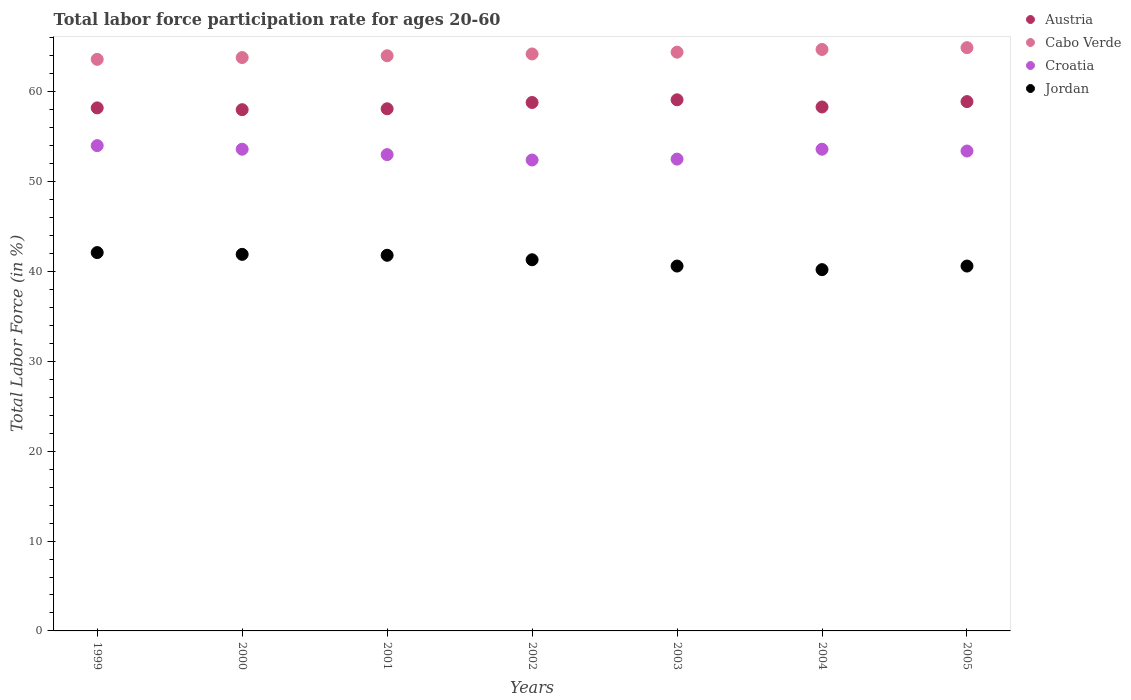How many different coloured dotlines are there?
Give a very brief answer. 4. Is the number of dotlines equal to the number of legend labels?
Your answer should be compact. Yes. What is the labor force participation rate in Austria in 2001?
Your response must be concise. 58.1. Across all years, what is the maximum labor force participation rate in Austria?
Your answer should be very brief. 59.1. Across all years, what is the minimum labor force participation rate in Croatia?
Your answer should be compact. 52.4. In which year was the labor force participation rate in Cabo Verde maximum?
Give a very brief answer. 2005. What is the total labor force participation rate in Cabo Verde in the graph?
Offer a terse response. 449.6. What is the difference between the labor force participation rate in Jordan in 1999 and that in 2004?
Your answer should be compact. 1.9. What is the difference between the labor force participation rate in Croatia in 1999 and the labor force participation rate in Cabo Verde in 2001?
Your response must be concise. -10. What is the average labor force participation rate in Austria per year?
Your answer should be compact. 58.49. In the year 1999, what is the difference between the labor force participation rate in Austria and labor force participation rate in Croatia?
Ensure brevity in your answer.  4.2. In how many years, is the labor force participation rate in Cabo Verde greater than 56 %?
Ensure brevity in your answer.  7. What is the ratio of the labor force participation rate in Cabo Verde in 2002 to that in 2004?
Provide a short and direct response. 0.99. Is the labor force participation rate in Croatia in 2001 less than that in 2003?
Your answer should be very brief. No. Is the difference between the labor force participation rate in Austria in 1999 and 2005 greater than the difference between the labor force participation rate in Croatia in 1999 and 2005?
Offer a terse response. No. What is the difference between the highest and the second highest labor force participation rate in Cabo Verde?
Make the answer very short. 0.2. What is the difference between the highest and the lowest labor force participation rate in Austria?
Give a very brief answer. 1.1. Is the sum of the labor force participation rate in Cabo Verde in 1999 and 2001 greater than the maximum labor force participation rate in Austria across all years?
Ensure brevity in your answer.  Yes. Is it the case that in every year, the sum of the labor force participation rate in Croatia and labor force participation rate in Austria  is greater than the sum of labor force participation rate in Jordan and labor force participation rate in Cabo Verde?
Your answer should be very brief. Yes. Is it the case that in every year, the sum of the labor force participation rate in Croatia and labor force participation rate in Jordan  is greater than the labor force participation rate in Austria?
Offer a very short reply. Yes. How many dotlines are there?
Give a very brief answer. 4. Does the graph contain any zero values?
Keep it short and to the point. No. Where does the legend appear in the graph?
Your answer should be compact. Top right. What is the title of the graph?
Keep it short and to the point. Total labor force participation rate for ages 20-60. Does "Least developed countries" appear as one of the legend labels in the graph?
Provide a succinct answer. No. What is the Total Labor Force (in %) of Austria in 1999?
Your response must be concise. 58.2. What is the Total Labor Force (in %) in Cabo Verde in 1999?
Keep it short and to the point. 63.6. What is the Total Labor Force (in %) in Croatia in 1999?
Your answer should be very brief. 54. What is the Total Labor Force (in %) of Jordan in 1999?
Offer a very short reply. 42.1. What is the Total Labor Force (in %) of Austria in 2000?
Make the answer very short. 58. What is the Total Labor Force (in %) in Cabo Verde in 2000?
Keep it short and to the point. 63.8. What is the Total Labor Force (in %) in Croatia in 2000?
Ensure brevity in your answer.  53.6. What is the Total Labor Force (in %) in Jordan in 2000?
Keep it short and to the point. 41.9. What is the Total Labor Force (in %) of Austria in 2001?
Provide a succinct answer. 58.1. What is the Total Labor Force (in %) of Cabo Verde in 2001?
Offer a terse response. 64. What is the Total Labor Force (in %) of Croatia in 2001?
Provide a short and direct response. 53. What is the Total Labor Force (in %) of Jordan in 2001?
Provide a short and direct response. 41.8. What is the Total Labor Force (in %) of Austria in 2002?
Your answer should be very brief. 58.8. What is the Total Labor Force (in %) of Cabo Verde in 2002?
Ensure brevity in your answer.  64.2. What is the Total Labor Force (in %) in Croatia in 2002?
Make the answer very short. 52.4. What is the Total Labor Force (in %) in Jordan in 2002?
Keep it short and to the point. 41.3. What is the Total Labor Force (in %) in Austria in 2003?
Provide a short and direct response. 59.1. What is the Total Labor Force (in %) of Cabo Verde in 2003?
Give a very brief answer. 64.4. What is the Total Labor Force (in %) in Croatia in 2003?
Your answer should be compact. 52.5. What is the Total Labor Force (in %) of Jordan in 2003?
Your answer should be compact. 40.6. What is the Total Labor Force (in %) of Austria in 2004?
Offer a terse response. 58.3. What is the Total Labor Force (in %) of Cabo Verde in 2004?
Offer a terse response. 64.7. What is the Total Labor Force (in %) of Croatia in 2004?
Your response must be concise. 53.6. What is the Total Labor Force (in %) of Jordan in 2004?
Offer a very short reply. 40.2. What is the Total Labor Force (in %) of Austria in 2005?
Your answer should be very brief. 58.9. What is the Total Labor Force (in %) in Cabo Verde in 2005?
Your answer should be compact. 64.9. What is the Total Labor Force (in %) in Croatia in 2005?
Ensure brevity in your answer.  53.4. What is the Total Labor Force (in %) in Jordan in 2005?
Your response must be concise. 40.6. Across all years, what is the maximum Total Labor Force (in %) in Austria?
Ensure brevity in your answer.  59.1. Across all years, what is the maximum Total Labor Force (in %) of Cabo Verde?
Offer a very short reply. 64.9. Across all years, what is the maximum Total Labor Force (in %) of Croatia?
Your answer should be very brief. 54. Across all years, what is the maximum Total Labor Force (in %) of Jordan?
Provide a short and direct response. 42.1. Across all years, what is the minimum Total Labor Force (in %) in Austria?
Your response must be concise. 58. Across all years, what is the minimum Total Labor Force (in %) of Cabo Verde?
Your response must be concise. 63.6. Across all years, what is the minimum Total Labor Force (in %) in Croatia?
Offer a terse response. 52.4. Across all years, what is the minimum Total Labor Force (in %) in Jordan?
Ensure brevity in your answer.  40.2. What is the total Total Labor Force (in %) of Austria in the graph?
Give a very brief answer. 409.4. What is the total Total Labor Force (in %) of Cabo Verde in the graph?
Provide a short and direct response. 449.6. What is the total Total Labor Force (in %) in Croatia in the graph?
Provide a short and direct response. 372.5. What is the total Total Labor Force (in %) of Jordan in the graph?
Provide a succinct answer. 288.5. What is the difference between the Total Labor Force (in %) of Austria in 1999 and that in 2000?
Keep it short and to the point. 0.2. What is the difference between the Total Labor Force (in %) in Croatia in 1999 and that in 2000?
Ensure brevity in your answer.  0.4. What is the difference between the Total Labor Force (in %) in Jordan in 1999 and that in 2000?
Give a very brief answer. 0.2. What is the difference between the Total Labor Force (in %) of Austria in 1999 and that in 2001?
Offer a very short reply. 0.1. What is the difference between the Total Labor Force (in %) in Cabo Verde in 1999 and that in 2001?
Your answer should be very brief. -0.4. What is the difference between the Total Labor Force (in %) of Croatia in 1999 and that in 2001?
Provide a short and direct response. 1. What is the difference between the Total Labor Force (in %) of Jordan in 1999 and that in 2001?
Give a very brief answer. 0.3. What is the difference between the Total Labor Force (in %) of Austria in 1999 and that in 2002?
Provide a short and direct response. -0.6. What is the difference between the Total Labor Force (in %) in Cabo Verde in 1999 and that in 2002?
Provide a short and direct response. -0.6. What is the difference between the Total Labor Force (in %) of Jordan in 1999 and that in 2002?
Offer a very short reply. 0.8. What is the difference between the Total Labor Force (in %) in Austria in 1999 and that in 2003?
Provide a succinct answer. -0.9. What is the difference between the Total Labor Force (in %) of Austria in 1999 and that in 2004?
Make the answer very short. -0.1. What is the difference between the Total Labor Force (in %) of Cabo Verde in 1999 and that in 2004?
Provide a succinct answer. -1.1. What is the difference between the Total Labor Force (in %) of Croatia in 1999 and that in 2004?
Make the answer very short. 0.4. What is the difference between the Total Labor Force (in %) in Jordan in 1999 and that in 2004?
Make the answer very short. 1.9. What is the difference between the Total Labor Force (in %) of Austria in 1999 and that in 2005?
Your answer should be very brief. -0.7. What is the difference between the Total Labor Force (in %) in Cabo Verde in 1999 and that in 2005?
Make the answer very short. -1.3. What is the difference between the Total Labor Force (in %) of Jordan in 1999 and that in 2005?
Make the answer very short. 1.5. What is the difference between the Total Labor Force (in %) in Croatia in 2000 and that in 2001?
Keep it short and to the point. 0.6. What is the difference between the Total Labor Force (in %) in Austria in 2000 and that in 2002?
Make the answer very short. -0.8. What is the difference between the Total Labor Force (in %) in Cabo Verde in 2000 and that in 2002?
Keep it short and to the point. -0.4. What is the difference between the Total Labor Force (in %) of Croatia in 2000 and that in 2002?
Provide a succinct answer. 1.2. What is the difference between the Total Labor Force (in %) in Austria in 2000 and that in 2003?
Your answer should be very brief. -1.1. What is the difference between the Total Labor Force (in %) of Croatia in 2000 and that in 2003?
Keep it short and to the point. 1.1. What is the difference between the Total Labor Force (in %) of Jordan in 2000 and that in 2003?
Your answer should be very brief. 1.3. What is the difference between the Total Labor Force (in %) of Austria in 2000 and that in 2004?
Your answer should be very brief. -0.3. What is the difference between the Total Labor Force (in %) in Cabo Verde in 2000 and that in 2004?
Provide a succinct answer. -0.9. What is the difference between the Total Labor Force (in %) in Croatia in 2000 and that in 2004?
Keep it short and to the point. 0. What is the difference between the Total Labor Force (in %) in Jordan in 2000 and that in 2004?
Your answer should be compact. 1.7. What is the difference between the Total Labor Force (in %) in Austria in 2000 and that in 2005?
Your response must be concise. -0.9. What is the difference between the Total Labor Force (in %) of Cabo Verde in 2000 and that in 2005?
Your response must be concise. -1.1. What is the difference between the Total Labor Force (in %) in Jordan in 2000 and that in 2005?
Your answer should be very brief. 1.3. What is the difference between the Total Labor Force (in %) of Austria in 2001 and that in 2002?
Give a very brief answer. -0.7. What is the difference between the Total Labor Force (in %) in Croatia in 2001 and that in 2003?
Offer a very short reply. 0.5. What is the difference between the Total Labor Force (in %) of Croatia in 2001 and that in 2004?
Your answer should be compact. -0.6. What is the difference between the Total Labor Force (in %) of Cabo Verde in 2001 and that in 2005?
Your answer should be very brief. -0.9. What is the difference between the Total Labor Force (in %) in Croatia in 2001 and that in 2005?
Provide a succinct answer. -0.4. What is the difference between the Total Labor Force (in %) in Austria in 2002 and that in 2003?
Keep it short and to the point. -0.3. What is the difference between the Total Labor Force (in %) in Cabo Verde in 2002 and that in 2003?
Offer a terse response. -0.2. What is the difference between the Total Labor Force (in %) of Cabo Verde in 2002 and that in 2004?
Your answer should be compact. -0.5. What is the difference between the Total Labor Force (in %) of Croatia in 2002 and that in 2004?
Keep it short and to the point. -1.2. What is the difference between the Total Labor Force (in %) in Cabo Verde in 2002 and that in 2005?
Provide a succinct answer. -0.7. What is the difference between the Total Labor Force (in %) of Cabo Verde in 2003 and that in 2004?
Offer a very short reply. -0.3. What is the difference between the Total Labor Force (in %) of Austria in 2003 and that in 2005?
Keep it short and to the point. 0.2. What is the difference between the Total Labor Force (in %) in Croatia in 2003 and that in 2005?
Provide a short and direct response. -0.9. What is the difference between the Total Labor Force (in %) of Jordan in 2003 and that in 2005?
Offer a terse response. 0. What is the difference between the Total Labor Force (in %) of Austria in 2004 and that in 2005?
Provide a succinct answer. -0.6. What is the difference between the Total Labor Force (in %) in Croatia in 2004 and that in 2005?
Your answer should be very brief. 0.2. What is the difference between the Total Labor Force (in %) in Austria in 1999 and the Total Labor Force (in %) in Croatia in 2000?
Give a very brief answer. 4.6. What is the difference between the Total Labor Force (in %) of Austria in 1999 and the Total Labor Force (in %) of Jordan in 2000?
Your answer should be compact. 16.3. What is the difference between the Total Labor Force (in %) in Cabo Verde in 1999 and the Total Labor Force (in %) in Croatia in 2000?
Provide a succinct answer. 10. What is the difference between the Total Labor Force (in %) in Cabo Verde in 1999 and the Total Labor Force (in %) in Jordan in 2000?
Ensure brevity in your answer.  21.7. What is the difference between the Total Labor Force (in %) in Austria in 1999 and the Total Labor Force (in %) in Croatia in 2001?
Keep it short and to the point. 5.2. What is the difference between the Total Labor Force (in %) of Austria in 1999 and the Total Labor Force (in %) of Jordan in 2001?
Your answer should be very brief. 16.4. What is the difference between the Total Labor Force (in %) in Cabo Verde in 1999 and the Total Labor Force (in %) in Croatia in 2001?
Make the answer very short. 10.6. What is the difference between the Total Labor Force (in %) of Cabo Verde in 1999 and the Total Labor Force (in %) of Jordan in 2001?
Ensure brevity in your answer.  21.8. What is the difference between the Total Labor Force (in %) in Austria in 1999 and the Total Labor Force (in %) in Jordan in 2002?
Your response must be concise. 16.9. What is the difference between the Total Labor Force (in %) in Cabo Verde in 1999 and the Total Labor Force (in %) in Jordan in 2002?
Your response must be concise. 22.3. What is the difference between the Total Labor Force (in %) in Croatia in 1999 and the Total Labor Force (in %) in Jordan in 2002?
Provide a short and direct response. 12.7. What is the difference between the Total Labor Force (in %) of Cabo Verde in 1999 and the Total Labor Force (in %) of Croatia in 2003?
Your response must be concise. 11.1. What is the difference between the Total Labor Force (in %) in Austria in 1999 and the Total Labor Force (in %) in Croatia in 2004?
Offer a very short reply. 4.6. What is the difference between the Total Labor Force (in %) in Austria in 1999 and the Total Labor Force (in %) in Jordan in 2004?
Provide a short and direct response. 18. What is the difference between the Total Labor Force (in %) in Cabo Verde in 1999 and the Total Labor Force (in %) in Croatia in 2004?
Offer a terse response. 10. What is the difference between the Total Labor Force (in %) in Cabo Verde in 1999 and the Total Labor Force (in %) in Jordan in 2004?
Your answer should be compact. 23.4. What is the difference between the Total Labor Force (in %) in Croatia in 1999 and the Total Labor Force (in %) in Jordan in 2004?
Your response must be concise. 13.8. What is the difference between the Total Labor Force (in %) of Austria in 1999 and the Total Labor Force (in %) of Cabo Verde in 2005?
Your answer should be compact. -6.7. What is the difference between the Total Labor Force (in %) in Austria in 1999 and the Total Labor Force (in %) in Croatia in 2005?
Provide a succinct answer. 4.8. What is the difference between the Total Labor Force (in %) of Cabo Verde in 1999 and the Total Labor Force (in %) of Croatia in 2005?
Offer a terse response. 10.2. What is the difference between the Total Labor Force (in %) in Austria in 2000 and the Total Labor Force (in %) in Croatia in 2001?
Your response must be concise. 5. What is the difference between the Total Labor Force (in %) of Austria in 2000 and the Total Labor Force (in %) of Jordan in 2001?
Give a very brief answer. 16.2. What is the difference between the Total Labor Force (in %) of Cabo Verde in 2000 and the Total Labor Force (in %) of Croatia in 2001?
Provide a short and direct response. 10.8. What is the difference between the Total Labor Force (in %) in Croatia in 2000 and the Total Labor Force (in %) in Jordan in 2001?
Give a very brief answer. 11.8. What is the difference between the Total Labor Force (in %) in Austria in 2000 and the Total Labor Force (in %) in Croatia in 2002?
Give a very brief answer. 5.6. What is the difference between the Total Labor Force (in %) of Austria in 2000 and the Total Labor Force (in %) of Jordan in 2002?
Give a very brief answer. 16.7. What is the difference between the Total Labor Force (in %) in Austria in 2000 and the Total Labor Force (in %) in Croatia in 2003?
Your answer should be very brief. 5.5. What is the difference between the Total Labor Force (in %) in Cabo Verde in 2000 and the Total Labor Force (in %) in Croatia in 2003?
Your answer should be compact. 11.3. What is the difference between the Total Labor Force (in %) in Cabo Verde in 2000 and the Total Labor Force (in %) in Jordan in 2003?
Give a very brief answer. 23.2. What is the difference between the Total Labor Force (in %) in Cabo Verde in 2000 and the Total Labor Force (in %) in Jordan in 2004?
Provide a short and direct response. 23.6. What is the difference between the Total Labor Force (in %) in Austria in 2000 and the Total Labor Force (in %) in Cabo Verde in 2005?
Offer a very short reply. -6.9. What is the difference between the Total Labor Force (in %) in Austria in 2000 and the Total Labor Force (in %) in Jordan in 2005?
Offer a very short reply. 17.4. What is the difference between the Total Labor Force (in %) of Cabo Verde in 2000 and the Total Labor Force (in %) of Croatia in 2005?
Your answer should be compact. 10.4. What is the difference between the Total Labor Force (in %) of Cabo Verde in 2000 and the Total Labor Force (in %) of Jordan in 2005?
Provide a short and direct response. 23.2. What is the difference between the Total Labor Force (in %) in Austria in 2001 and the Total Labor Force (in %) in Cabo Verde in 2002?
Keep it short and to the point. -6.1. What is the difference between the Total Labor Force (in %) of Austria in 2001 and the Total Labor Force (in %) of Croatia in 2002?
Provide a succinct answer. 5.7. What is the difference between the Total Labor Force (in %) of Austria in 2001 and the Total Labor Force (in %) of Jordan in 2002?
Provide a short and direct response. 16.8. What is the difference between the Total Labor Force (in %) in Cabo Verde in 2001 and the Total Labor Force (in %) in Croatia in 2002?
Ensure brevity in your answer.  11.6. What is the difference between the Total Labor Force (in %) of Cabo Verde in 2001 and the Total Labor Force (in %) of Jordan in 2002?
Keep it short and to the point. 22.7. What is the difference between the Total Labor Force (in %) in Croatia in 2001 and the Total Labor Force (in %) in Jordan in 2002?
Your answer should be very brief. 11.7. What is the difference between the Total Labor Force (in %) in Austria in 2001 and the Total Labor Force (in %) in Jordan in 2003?
Offer a terse response. 17.5. What is the difference between the Total Labor Force (in %) in Cabo Verde in 2001 and the Total Labor Force (in %) in Croatia in 2003?
Offer a very short reply. 11.5. What is the difference between the Total Labor Force (in %) of Cabo Verde in 2001 and the Total Labor Force (in %) of Jordan in 2003?
Your answer should be very brief. 23.4. What is the difference between the Total Labor Force (in %) of Croatia in 2001 and the Total Labor Force (in %) of Jordan in 2003?
Your answer should be very brief. 12.4. What is the difference between the Total Labor Force (in %) of Austria in 2001 and the Total Labor Force (in %) of Croatia in 2004?
Provide a succinct answer. 4.5. What is the difference between the Total Labor Force (in %) of Austria in 2001 and the Total Labor Force (in %) of Jordan in 2004?
Ensure brevity in your answer.  17.9. What is the difference between the Total Labor Force (in %) in Cabo Verde in 2001 and the Total Labor Force (in %) in Jordan in 2004?
Make the answer very short. 23.8. What is the difference between the Total Labor Force (in %) in Austria in 2001 and the Total Labor Force (in %) in Jordan in 2005?
Your response must be concise. 17.5. What is the difference between the Total Labor Force (in %) in Cabo Verde in 2001 and the Total Labor Force (in %) in Croatia in 2005?
Offer a very short reply. 10.6. What is the difference between the Total Labor Force (in %) in Cabo Verde in 2001 and the Total Labor Force (in %) in Jordan in 2005?
Offer a very short reply. 23.4. What is the difference between the Total Labor Force (in %) in Austria in 2002 and the Total Labor Force (in %) in Jordan in 2003?
Make the answer very short. 18.2. What is the difference between the Total Labor Force (in %) of Cabo Verde in 2002 and the Total Labor Force (in %) of Jordan in 2003?
Your answer should be very brief. 23.6. What is the difference between the Total Labor Force (in %) of Austria in 2002 and the Total Labor Force (in %) of Jordan in 2004?
Provide a short and direct response. 18.6. What is the difference between the Total Labor Force (in %) of Austria in 2002 and the Total Labor Force (in %) of Croatia in 2005?
Provide a short and direct response. 5.4. What is the difference between the Total Labor Force (in %) in Cabo Verde in 2002 and the Total Labor Force (in %) in Jordan in 2005?
Give a very brief answer. 23.6. What is the difference between the Total Labor Force (in %) in Austria in 2003 and the Total Labor Force (in %) in Cabo Verde in 2004?
Provide a succinct answer. -5.6. What is the difference between the Total Labor Force (in %) of Austria in 2003 and the Total Labor Force (in %) of Croatia in 2004?
Your response must be concise. 5.5. What is the difference between the Total Labor Force (in %) of Cabo Verde in 2003 and the Total Labor Force (in %) of Croatia in 2004?
Provide a succinct answer. 10.8. What is the difference between the Total Labor Force (in %) of Cabo Verde in 2003 and the Total Labor Force (in %) of Jordan in 2004?
Keep it short and to the point. 24.2. What is the difference between the Total Labor Force (in %) in Croatia in 2003 and the Total Labor Force (in %) in Jordan in 2004?
Provide a succinct answer. 12.3. What is the difference between the Total Labor Force (in %) in Austria in 2003 and the Total Labor Force (in %) in Jordan in 2005?
Offer a terse response. 18.5. What is the difference between the Total Labor Force (in %) in Cabo Verde in 2003 and the Total Labor Force (in %) in Croatia in 2005?
Keep it short and to the point. 11. What is the difference between the Total Labor Force (in %) of Cabo Verde in 2003 and the Total Labor Force (in %) of Jordan in 2005?
Your response must be concise. 23.8. What is the difference between the Total Labor Force (in %) of Cabo Verde in 2004 and the Total Labor Force (in %) of Jordan in 2005?
Ensure brevity in your answer.  24.1. What is the difference between the Total Labor Force (in %) in Croatia in 2004 and the Total Labor Force (in %) in Jordan in 2005?
Offer a very short reply. 13. What is the average Total Labor Force (in %) in Austria per year?
Make the answer very short. 58.49. What is the average Total Labor Force (in %) in Cabo Verde per year?
Keep it short and to the point. 64.23. What is the average Total Labor Force (in %) in Croatia per year?
Offer a terse response. 53.21. What is the average Total Labor Force (in %) of Jordan per year?
Your answer should be compact. 41.21. In the year 1999, what is the difference between the Total Labor Force (in %) of Austria and Total Labor Force (in %) of Jordan?
Give a very brief answer. 16.1. In the year 1999, what is the difference between the Total Labor Force (in %) in Cabo Verde and Total Labor Force (in %) in Croatia?
Your answer should be very brief. 9.6. In the year 1999, what is the difference between the Total Labor Force (in %) in Cabo Verde and Total Labor Force (in %) in Jordan?
Offer a terse response. 21.5. In the year 2000, what is the difference between the Total Labor Force (in %) of Austria and Total Labor Force (in %) of Croatia?
Provide a succinct answer. 4.4. In the year 2000, what is the difference between the Total Labor Force (in %) in Austria and Total Labor Force (in %) in Jordan?
Offer a very short reply. 16.1. In the year 2000, what is the difference between the Total Labor Force (in %) of Cabo Verde and Total Labor Force (in %) of Jordan?
Your answer should be compact. 21.9. In the year 2000, what is the difference between the Total Labor Force (in %) in Croatia and Total Labor Force (in %) in Jordan?
Offer a terse response. 11.7. In the year 2001, what is the difference between the Total Labor Force (in %) of Austria and Total Labor Force (in %) of Cabo Verde?
Give a very brief answer. -5.9. In the year 2001, what is the difference between the Total Labor Force (in %) in Austria and Total Labor Force (in %) in Jordan?
Provide a short and direct response. 16.3. In the year 2001, what is the difference between the Total Labor Force (in %) of Cabo Verde and Total Labor Force (in %) of Croatia?
Your response must be concise. 11. In the year 2001, what is the difference between the Total Labor Force (in %) of Cabo Verde and Total Labor Force (in %) of Jordan?
Provide a succinct answer. 22.2. In the year 2001, what is the difference between the Total Labor Force (in %) of Croatia and Total Labor Force (in %) of Jordan?
Ensure brevity in your answer.  11.2. In the year 2002, what is the difference between the Total Labor Force (in %) in Austria and Total Labor Force (in %) in Cabo Verde?
Make the answer very short. -5.4. In the year 2002, what is the difference between the Total Labor Force (in %) of Austria and Total Labor Force (in %) of Croatia?
Ensure brevity in your answer.  6.4. In the year 2002, what is the difference between the Total Labor Force (in %) in Cabo Verde and Total Labor Force (in %) in Croatia?
Offer a very short reply. 11.8. In the year 2002, what is the difference between the Total Labor Force (in %) in Cabo Verde and Total Labor Force (in %) in Jordan?
Offer a terse response. 22.9. In the year 2003, what is the difference between the Total Labor Force (in %) of Austria and Total Labor Force (in %) of Cabo Verde?
Keep it short and to the point. -5.3. In the year 2003, what is the difference between the Total Labor Force (in %) in Austria and Total Labor Force (in %) in Croatia?
Ensure brevity in your answer.  6.6. In the year 2003, what is the difference between the Total Labor Force (in %) in Austria and Total Labor Force (in %) in Jordan?
Provide a short and direct response. 18.5. In the year 2003, what is the difference between the Total Labor Force (in %) in Cabo Verde and Total Labor Force (in %) in Jordan?
Provide a succinct answer. 23.8. In the year 2003, what is the difference between the Total Labor Force (in %) of Croatia and Total Labor Force (in %) of Jordan?
Your answer should be very brief. 11.9. In the year 2004, what is the difference between the Total Labor Force (in %) in Austria and Total Labor Force (in %) in Croatia?
Your answer should be very brief. 4.7. In the year 2004, what is the difference between the Total Labor Force (in %) of Cabo Verde and Total Labor Force (in %) of Croatia?
Your answer should be very brief. 11.1. In the year 2004, what is the difference between the Total Labor Force (in %) of Croatia and Total Labor Force (in %) of Jordan?
Make the answer very short. 13.4. In the year 2005, what is the difference between the Total Labor Force (in %) in Austria and Total Labor Force (in %) in Jordan?
Provide a succinct answer. 18.3. In the year 2005, what is the difference between the Total Labor Force (in %) of Cabo Verde and Total Labor Force (in %) of Jordan?
Offer a very short reply. 24.3. In the year 2005, what is the difference between the Total Labor Force (in %) of Croatia and Total Labor Force (in %) of Jordan?
Your response must be concise. 12.8. What is the ratio of the Total Labor Force (in %) of Croatia in 1999 to that in 2000?
Offer a terse response. 1.01. What is the ratio of the Total Labor Force (in %) in Jordan in 1999 to that in 2000?
Give a very brief answer. 1. What is the ratio of the Total Labor Force (in %) of Croatia in 1999 to that in 2001?
Offer a very short reply. 1.02. What is the ratio of the Total Labor Force (in %) of Croatia in 1999 to that in 2002?
Provide a succinct answer. 1.03. What is the ratio of the Total Labor Force (in %) of Jordan in 1999 to that in 2002?
Ensure brevity in your answer.  1.02. What is the ratio of the Total Labor Force (in %) of Cabo Verde in 1999 to that in 2003?
Ensure brevity in your answer.  0.99. What is the ratio of the Total Labor Force (in %) in Croatia in 1999 to that in 2003?
Offer a terse response. 1.03. What is the ratio of the Total Labor Force (in %) in Jordan in 1999 to that in 2003?
Ensure brevity in your answer.  1.04. What is the ratio of the Total Labor Force (in %) of Austria in 1999 to that in 2004?
Your answer should be compact. 1. What is the ratio of the Total Labor Force (in %) in Cabo Verde in 1999 to that in 2004?
Provide a succinct answer. 0.98. What is the ratio of the Total Labor Force (in %) of Croatia in 1999 to that in 2004?
Keep it short and to the point. 1.01. What is the ratio of the Total Labor Force (in %) of Jordan in 1999 to that in 2004?
Provide a succinct answer. 1.05. What is the ratio of the Total Labor Force (in %) of Cabo Verde in 1999 to that in 2005?
Offer a terse response. 0.98. What is the ratio of the Total Labor Force (in %) in Croatia in 1999 to that in 2005?
Your response must be concise. 1.01. What is the ratio of the Total Labor Force (in %) in Jordan in 1999 to that in 2005?
Offer a very short reply. 1.04. What is the ratio of the Total Labor Force (in %) in Austria in 2000 to that in 2001?
Keep it short and to the point. 1. What is the ratio of the Total Labor Force (in %) in Cabo Verde in 2000 to that in 2001?
Your response must be concise. 1. What is the ratio of the Total Labor Force (in %) of Croatia in 2000 to that in 2001?
Make the answer very short. 1.01. What is the ratio of the Total Labor Force (in %) of Austria in 2000 to that in 2002?
Provide a succinct answer. 0.99. What is the ratio of the Total Labor Force (in %) in Croatia in 2000 to that in 2002?
Ensure brevity in your answer.  1.02. What is the ratio of the Total Labor Force (in %) in Jordan in 2000 to that in 2002?
Keep it short and to the point. 1.01. What is the ratio of the Total Labor Force (in %) of Austria in 2000 to that in 2003?
Offer a terse response. 0.98. What is the ratio of the Total Labor Force (in %) in Jordan in 2000 to that in 2003?
Your answer should be very brief. 1.03. What is the ratio of the Total Labor Force (in %) in Austria in 2000 to that in 2004?
Provide a succinct answer. 0.99. What is the ratio of the Total Labor Force (in %) of Cabo Verde in 2000 to that in 2004?
Give a very brief answer. 0.99. What is the ratio of the Total Labor Force (in %) in Jordan in 2000 to that in 2004?
Offer a very short reply. 1.04. What is the ratio of the Total Labor Force (in %) of Austria in 2000 to that in 2005?
Provide a succinct answer. 0.98. What is the ratio of the Total Labor Force (in %) of Cabo Verde in 2000 to that in 2005?
Make the answer very short. 0.98. What is the ratio of the Total Labor Force (in %) in Jordan in 2000 to that in 2005?
Your answer should be very brief. 1.03. What is the ratio of the Total Labor Force (in %) of Cabo Verde in 2001 to that in 2002?
Ensure brevity in your answer.  1. What is the ratio of the Total Labor Force (in %) in Croatia in 2001 to that in 2002?
Keep it short and to the point. 1.01. What is the ratio of the Total Labor Force (in %) of Jordan in 2001 to that in 2002?
Keep it short and to the point. 1.01. What is the ratio of the Total Labor Force (in %) of Austria in 2001 to that in 2003?
Your answer should be compact. 0.98. What is the ratio of the Total Labor Force (in %) of Croatia in 2001 to that in 2003?
Provide a short and direct response. 1.01. What is the ratio of the Total Labor Force (in %) in Jordan in 2001 to that in 2003?
Your response must be concise. 1.03. What is the ratio of the Total Labor Force (in %) in Austria in 2001 to that in 2004?
Offer a very short reply. 1. What is the ratio of the Total Labor Force (in %) of Cabo Verde in 2001 to that in 2004?
Keep it short and to the point. 0.99. What is the ratio of the Total Labor Force (in %) of Jordan in 2001 to that in 2004?
Provide a succinct answer. 1.04. What is the ratio of the Total Labor Force (in %) of Austria in 2001 to that in 2005?
Make the answer very short. 0.99. What is the ratio of the Total Labor Force (in %) of Cabo Verde in 2001 to that in 2005?
Provide a succinct answer. 0.99. What is the ratio of the Total Labor Force (in %) of Croatia in 2001 to that in 2005?
Provide a succinct answer. 0.99. What is the ratio of the Total Labor Force (in %) in Jordan in 2001 to that in 2005?
Provide a succinct answer. 1.03. What is the ratio of the Total Labor Force (in %) in Austria in 2002 to that in 2003?
Provide a succinct answer. 0.99. What is the ratio of the Total Labor Force (in %) of Cabo Verde in 2002 to that in 2003?
Offer a very short reply. 1. What is the ratio of the Total Labor Force (in %) in Croatia in 2002 to that in 2003?
Ensure brevity in your answer.  1. What is the ratio of the Total Labor Force (in %) of Jordan in 2002 to that in 2003?
Offer a very short reply. 1.02. What is the ratio of the Total Labor Force (in %) of Austria in 2002 to that in 2004?
Give a very brief answer. 1.01. What is the ratio of the Total Labor Force (in %) of Cabo Verde in 2002 to that in 2004?
Offer a very short reply. 0.99. What is the ratio of the Total Labor Force (in %) in Croatia in 2002 to that in 2004?
Ensure brevity in your answer.  0.98. What is the ratio of the Total Labor Force (in %) of Jordan in 2002 to that in 2004?
Ensure brevity in your answer.  1.03. What is the ratio of the Total Labor Force (in %) in Austria in 2002 to that in 2005?
Your answer should be very brief. 1. What is the ratio of the Total Labor Force (in %) in Croatia in 2002 to that in 2005?
Your answer should be compact. 0.98. What is the ratio of the Total Labor Force (in %) of Jordan in 2002 to that in 2005?
Keep it short and to the point. 1.02. What is the ratio of the Total Labor Force (in %) in Austria in 2003 to that in 2004?
Offer a terse response. 1.01. What is the ratio of the Total Labor Force (in %) of Cabo Verde in 2003 to that in 2004?
Offer a very short reply. 1. What is the ratio of the Total Labor Force (in %) of Croatia in 2003 to that in 2004?
Offer a terse response. 0.98. What is the ratio of the Total Labor Force (in %) in Jordan in 2003 to that in 2004?
Your answer should be very brief. 1.01. What is the ratio of the Total Labor Force (in %) of Austria in 2003 to that in 2005?
Offer a terse response. 1. What is the ratio of the Total Labor Force (in %) in Croatia in 2003 to that in 2005?
Provide a succinct answer. 0.98. What is the ratio of the Total Labor Force (in %) of Jordan in 2003 to that in 2005?
Keep it short and to the point. 1. What is the difference between the highest and the second highest Total Labor Force (in %) of Croatia?
Your response must be concise. 0.4. What is the difference between the highest and the lowest Total Labor Force (in %) of Austria?
Your response must be concise. 1.1. What is the difference between the highest and the lowest Total Labor Force (in %) in Cabo Verde?
Give a very brief answer. 1.3. What is the difference between the highest and the lowest Total Labor Force (in %) in Jordan?
Provide a short and direct response. 1.9. 